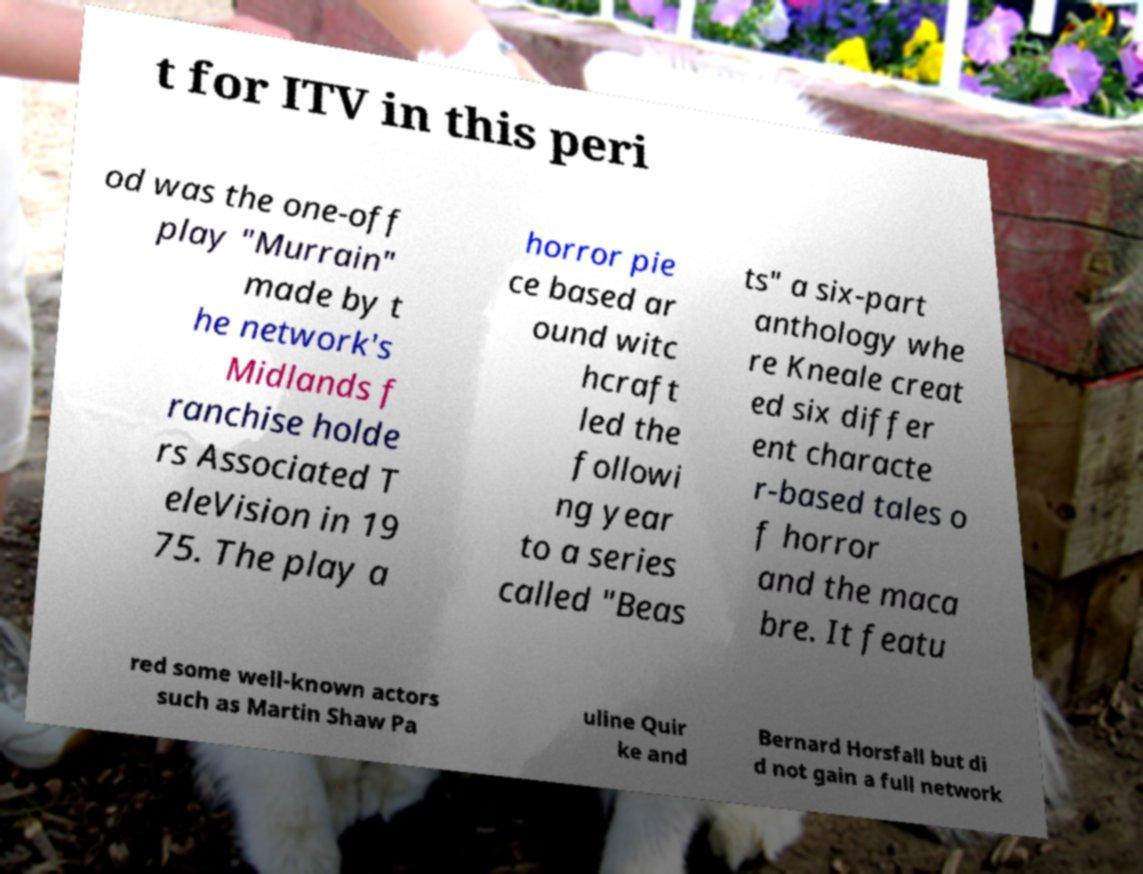Could you assist in decoding the text presented in this image and type it out clearly? t for ITV in this peri od was the one-off play "Murrain" made by t he network's Midlands f ranchise holde rs Associated T eleVision in 19 75. The play a horror pie ce based ar ound witc hcraft led the followi ng year to a series called "Beas ts" a six-part anthology whe re Kneale creat ed six differ ent characte r-based tales o f horror and the maca bre. It featu red some well-known actors such as Martin Shaw Pa uline Quir ke and Bernard Horsfall but di d not gain a full network 